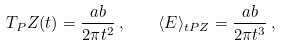<formula> <loc_0><loc_0><loc_500><loc_500>T _ { P } Z ( t ) = \frac { a b } { 2 \pi t ^ { 2 } } \, , \quad \langle E \rangle _ { t P Z } = \frac { a b } { 2 \pi t ^ { 3 } } \, ,</formula> 